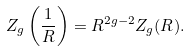<formula> <loc_0><loc_0><loc_500><loc_500>Z _ { g } \left ( { \frac { 1 } { R } } \right ) = R ^ { 2 g - 2 } Z _ { g } ( R ) .</formula> 